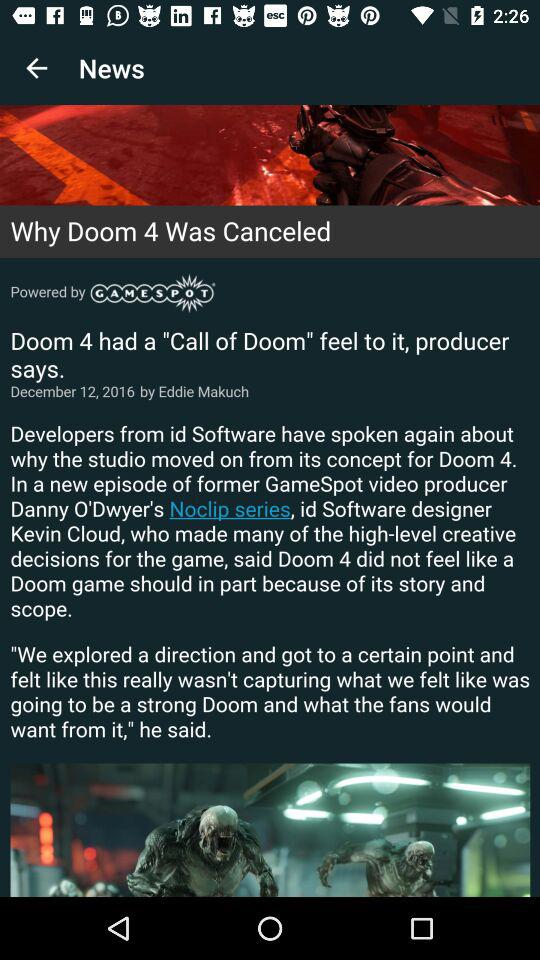The article is powered by what company? The article is powered by "GAMESPOT". 